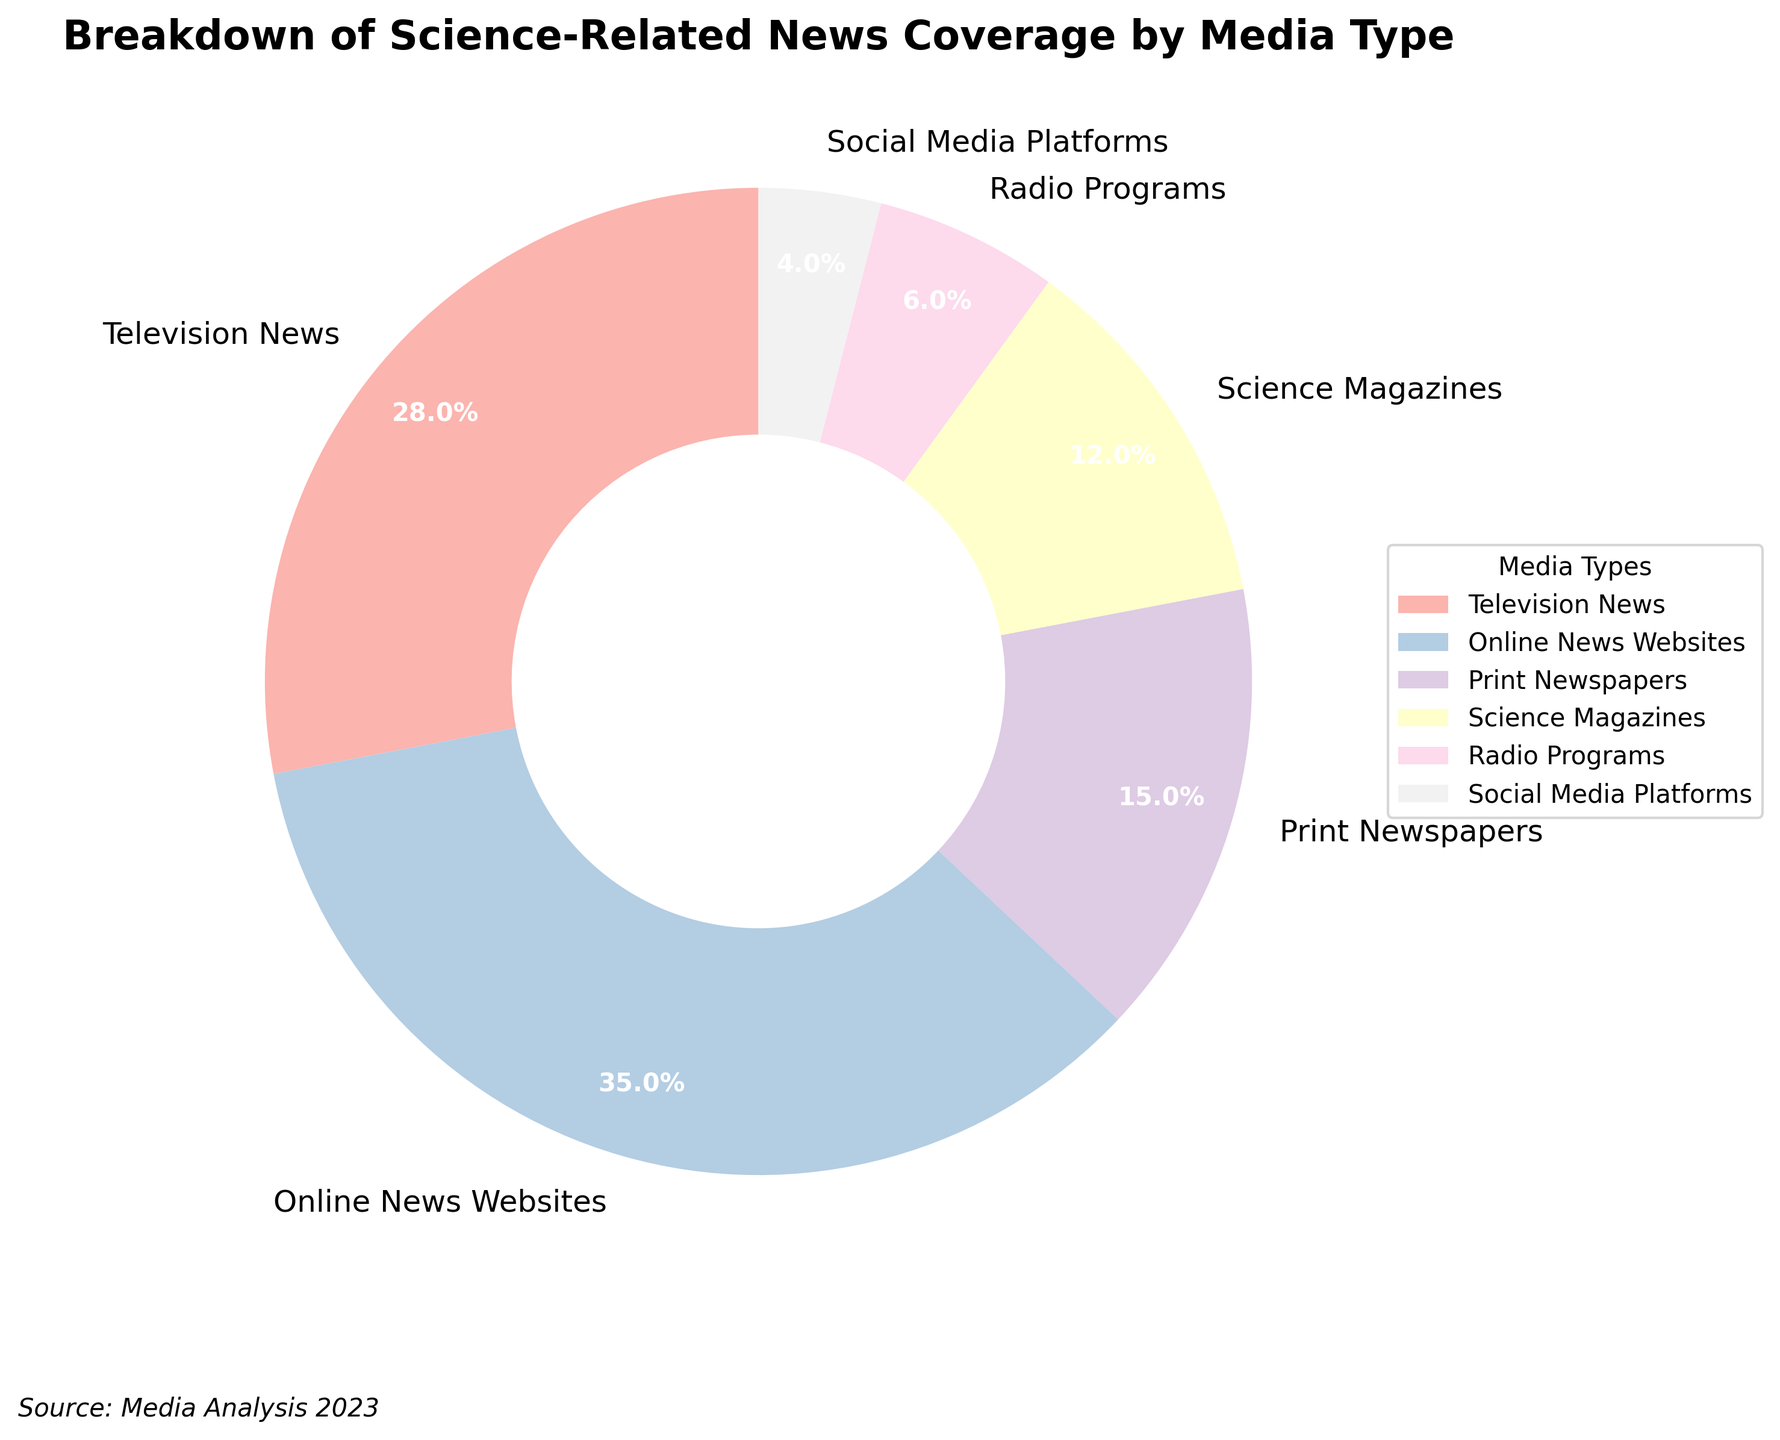What percentage of science-related news coverage is dedicated to Television News and Print Newspapers combined? To find the combined percentage, you need to add the percentage values of Television News and Print Newspapers. Television News is 28%, and Print Newspapers is 15%. Adding these together gives 28% + 15% = 43%.
Answer: 43% Which media type has a higher percentage of science-related news coverage, Online News Websites or Science Magazines? Comparisons are made by looking at the percentage values. Online News Websites have 35%, while Science Magazines have 12%. Since 35% is greater than 12%, Online News Websites have a higher percentage.
Answer: Online News Websites Among the media types listed, what is the total percentage of news coverage taken up by the three least prominent media types? To find this, identify the three media types with the smallest percentages and add them. The three least prominent are Social Media Platforms (4%), Radio Programs (6%), and Science Magazines (12%). Adding these gives 4% + 6% + 12% = 22%.
Answer: 22% What is the difference in percentage points between the media type with the highest coverage and the media type with the lowest coverage? First, identify the media type with the highest percentage (Online News Websites at 35%) and the one with the lowest percentage (Social Media Platforms at 4%). Subtract the lowest from the highest: 35% - 4% = 31%.
Answer: 31% What percentage of science-related news coverage is represented by the media types that fall between 10% and 30%? Identify the media types in this range and add their percentages. The media types are Television News (28%), Print Newspapers (15%), and Science Magazines (12%). Adding these gives 28% + 15% + 12% = 55%.
Answer: 55% 